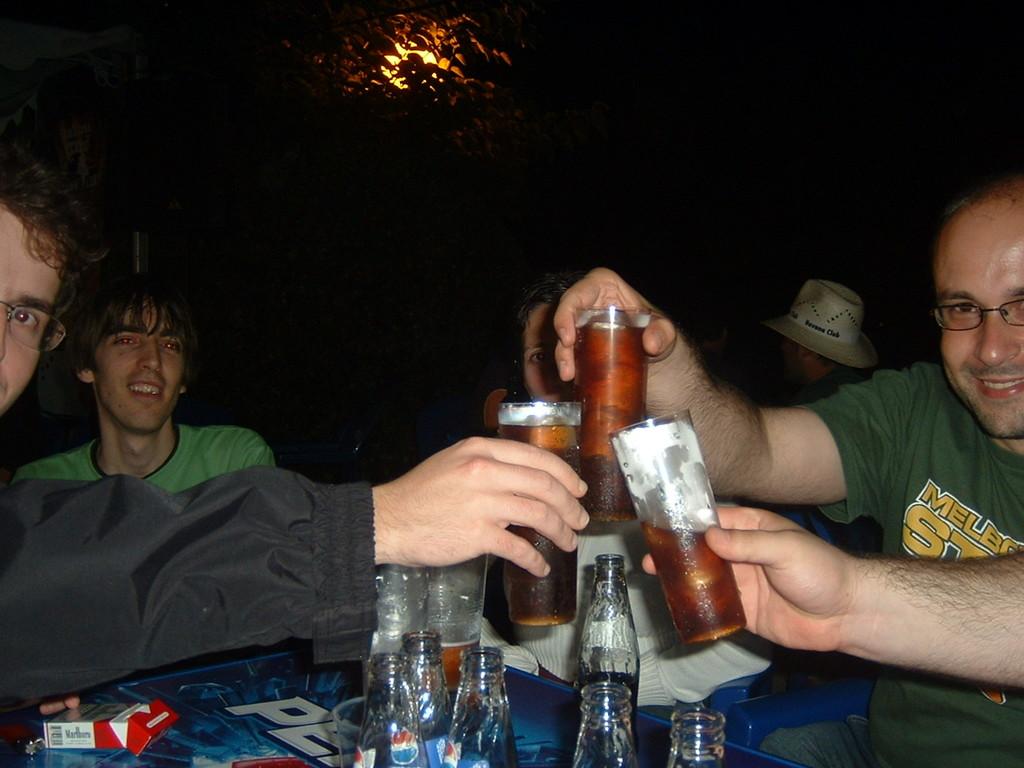What brand of cigarettes is on the table?
Provide a short and direct response. Marlboro. 